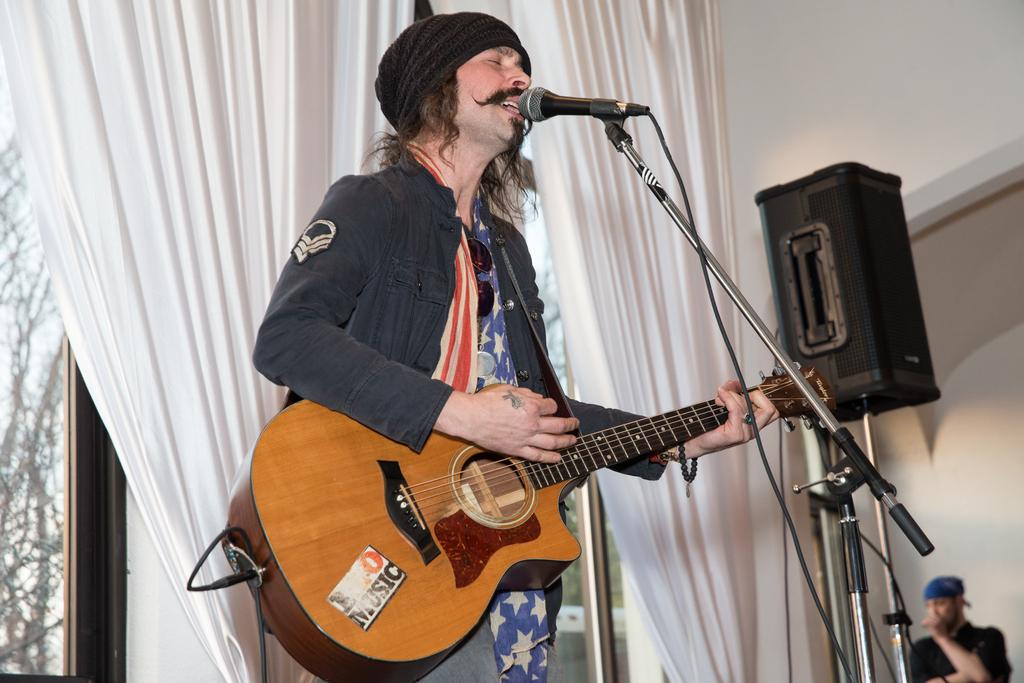What is the man in the image doing? The man is singing in the image. What is the man holding while singing? The man is holding a microphone in the image. What musical instrument is the man playing? The man is playing a guitar in the image. What type of celery is the man using as a prop while singing? There is no celery present in the image. 